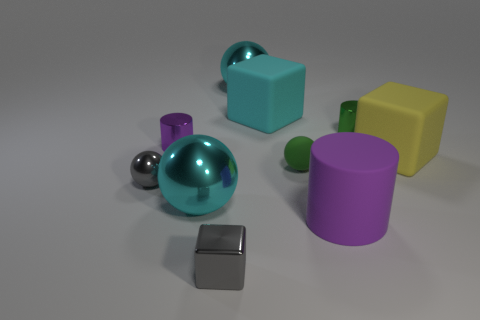Subtract all balls. How many objects are left? 6 Add 2 small purple rubber cylinders. How many small purple rubber cylinders exist? 2 Subtract 0 brown balls. How many objects are left? 10 Subtract all big green objects. Subtract all tiny rubber spheres. How many objects are left? 9 Add 5 gray cubes. How many gray cubes are left? 6 